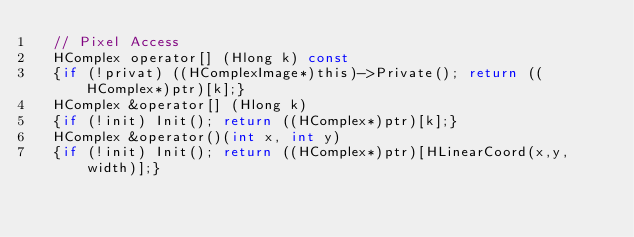Convert code to text. <code><loc_0><loc_0><loc_500><loc_500><_C_>  // Pixel Access
  HComplex operator[] (Hlong k) const
  {if (!privat) ((HComplexImage*)this)->Private(); return ((HComplex*)ptr)[k];}
  HComplex &operator[] (Hlong k)
  {if (!init) Init(); return ((HComplex*)ptr)[k];}
  HComplex &operator()(int x, int y) 
  {if (!init) Init(); return ((HComplex*)ptr)[HLinearCoord(x,y,width)];}</code> 